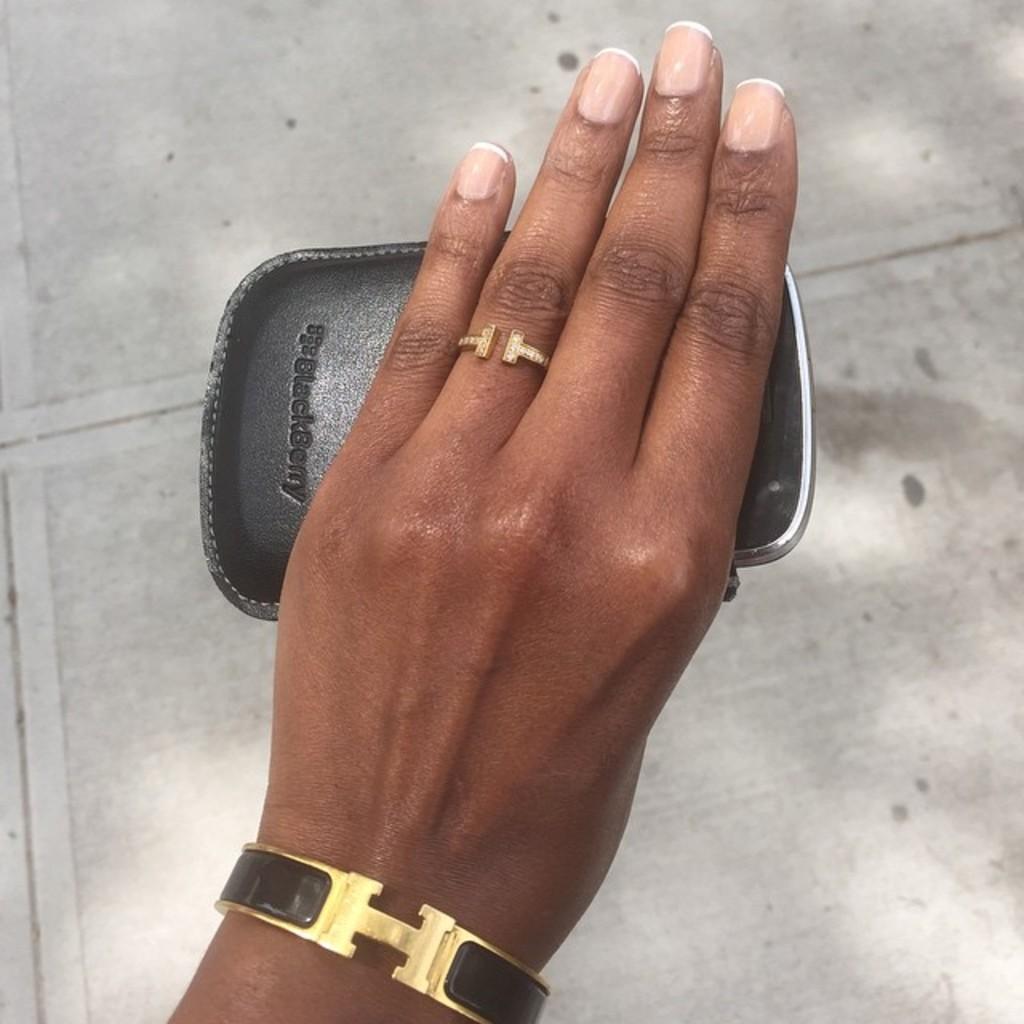What kind of phone or phone case is this?
Keep it short and to the point. Blackberry. 